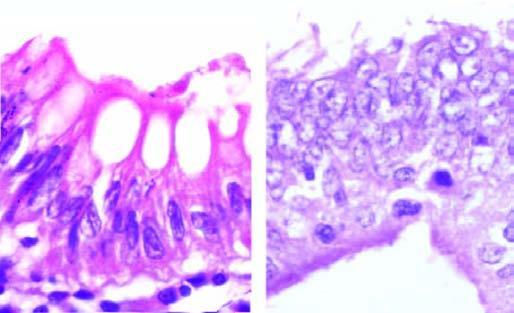s microscopic appearance of loss of nuclear polarity b contrasted with normal basal polarity in columnar epithelium a?
Answer the question using a single word or phrase. Yes 